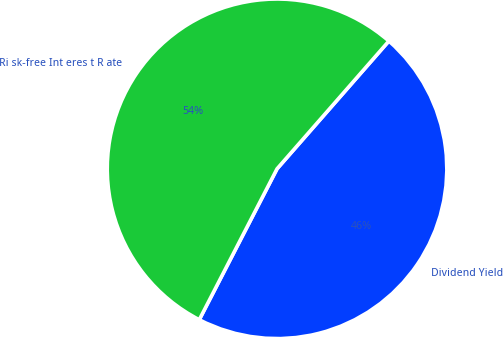Convert chart to OTSL. <chart><loc_0><loc_0><loc_500><loc_500><pie_chart><fcel>Dividend Yield<fcel>Ri sk-free Int eres t R ate<nl><fcel>46.13%<fcel>53.87%<nl></chart> 